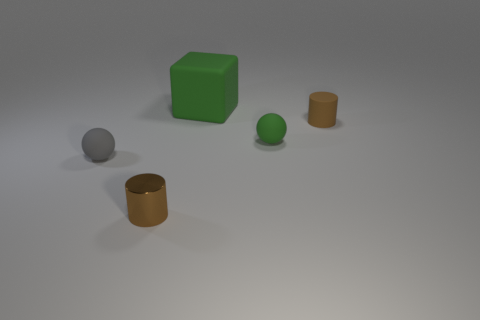Is there anything else that has the same size as the green block?
Offer a very short reply. No. There is a object to the left of the small brown shiny cylinder; is it the same shape as the big rubber thing?
Keep it short and to the point. No. There is another tiny thing that is the same shape as the tiny metallic object; what is its material?
Offer a very short reply. Rubber. How many things are tiny spheres behind the gray sphere or objects that are in front of the big cube?
Your answer should be very brief. 4. There is a small metal cylinder; is its color the same as the rubber cylinder that is right of the rubber block?
Your answer should be compact. Yes. The tiny brown thing that is the same material as the large green cube is what shape?
Offer a very short reply. Cylinder. How many small brown things are there?
Make the answer very short. 2. How many objects are either things on the right side of the metallic cylinder or tiny blue metal cylinders?
Keep it short and to the point. 3. Is the color of the tiny cylinder that is on the right side of the tiny metallic object the same as the tiny shiny cylinder?
Provide a succinct answer. Yes. How many tiny things are either green spheres or spheres?
Ensure brevity in your answer.  2. 